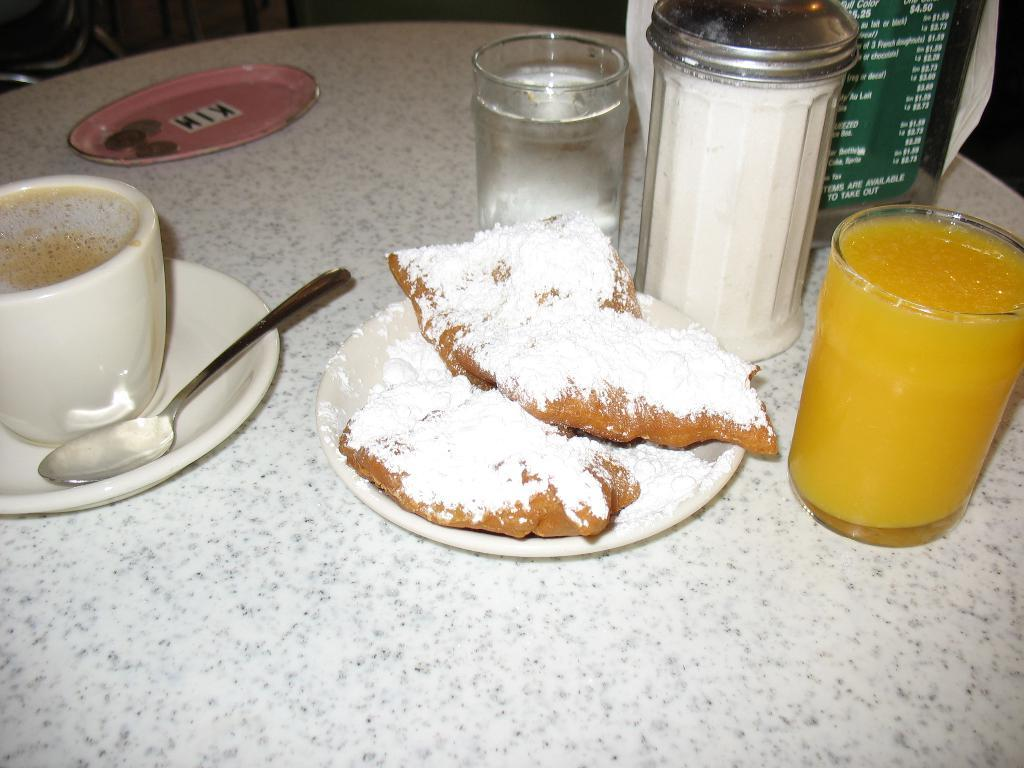What type of drink is in the glass on the table? There is a glass of juice on the table. What other items are on the table? There are plates, a cup of coffee with a saucer, a spoon, another glass of juice, and a plate containing a food item on the table. What type of beverage is in the cup on the table? There is a cup of coffee with a saucer on the table. What utensil is on the table? There is a spoon on the table. What color is the grape on the table? There is no grape present on the table in the image. What type of wire is used to hold the pencil on the table? There is no pencil or wire present on the table in the image. 